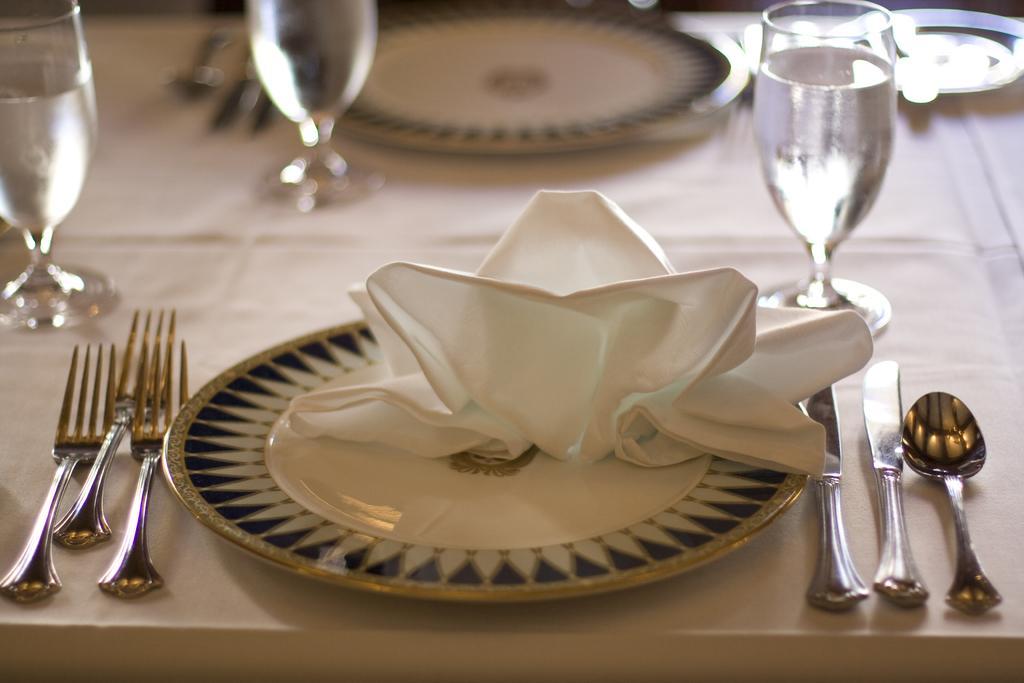Can you describe this image briefly? This image has two plates and forks at left side and knife and spoon at right side, few glasses having water in it. 